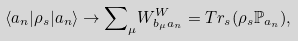<formula> <loc_0><loc_0><loc_500><loc_500>\langle a _ { n } | \rho _ { s } | a _ { n } \rangle \to { \sum } _ { \mu } W ^ { W } _ { b _ { \mu } a _ { n } } = T r _ { s } ( \rho _ { s } \mathbb { P } _ { a _ { n } } ) ,</formula> 